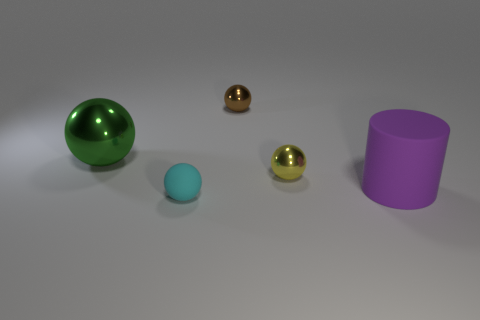What is the material of the large green thing that is the same shape as the yellow object?
Provide a short and direct response. Metal. There is a metallic ball that is behind the large thing that is left of the big thing that is right of the big shiny object; what is its color?
Give a very brief answer. Brown. Does the tiny object in front of the tiny yellow object have the same shape as the small yellow object?
Keep it short and to the point. Yes. What material is the large green object?
Your answer should be very brief. Metal. What shape is the large object on the right side of the object that is to the left of the object that is in front of the matte cylinder?
Provide a short and direct response. Cylinder. How many other things are there of the same shape as the big purple thing?
Offer a very short reply. 0. Do the large matte cylinder and the small ball in front of the yellow metallic object have the same color?
Offer a very short reply. No. What number of large green metal balls are there?
Your answer should be very brief. 1. What number of objects are either large green shiny balls or tiny things?
Provide a succinct answer. 4. There is a brown object; are there any large purple things to the left of it?
Offer a terse response. No. 